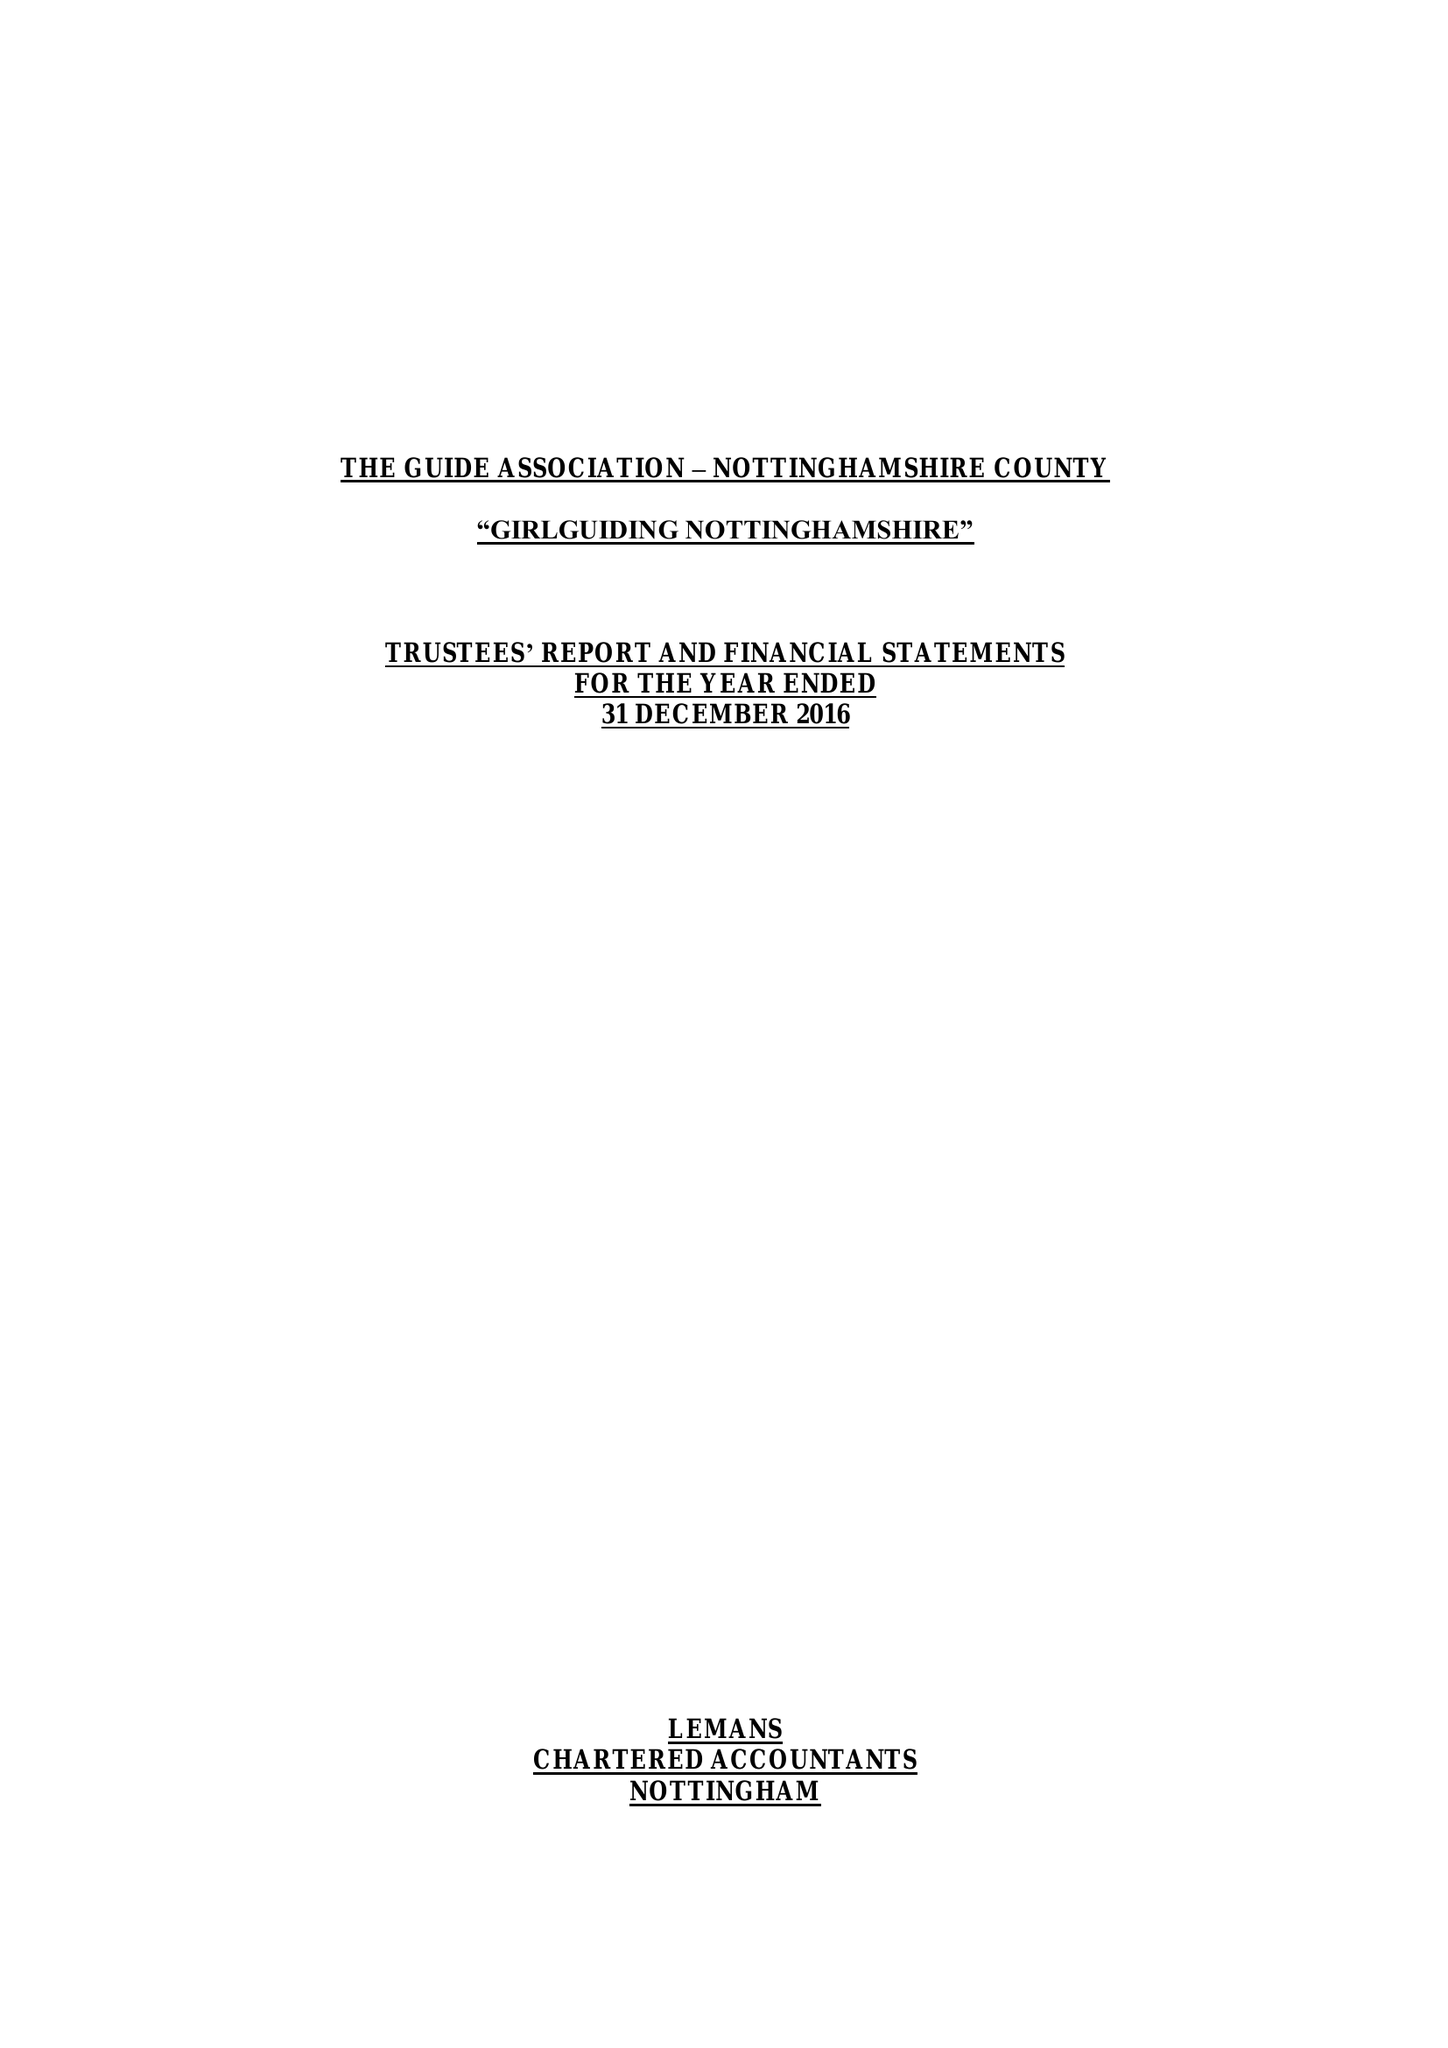What is the value for the spending_annually_in_british_pounds?
Answer the question using a single word or phrase. 211338.00 